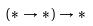<formula> <loc_0><loc_0><loc_500><loc_500>( * \rightarrow * ) \rightarrow *</formula> 